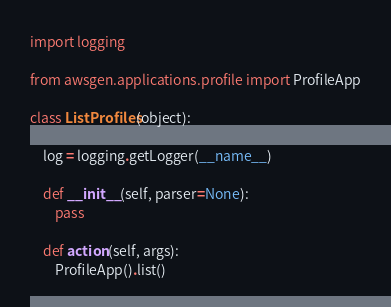<code> <loc_0><loc_0><loc_500><loc_500><_Python_>import logging

from awsgen.applications.profile import ProfileApp

class ListProfiles(object):

    log = logging.getLogger(__name__)

    def __init__(self, parser=None):
        pass
        
    def action(self, args):
        ProfileApp().list()
</code> 